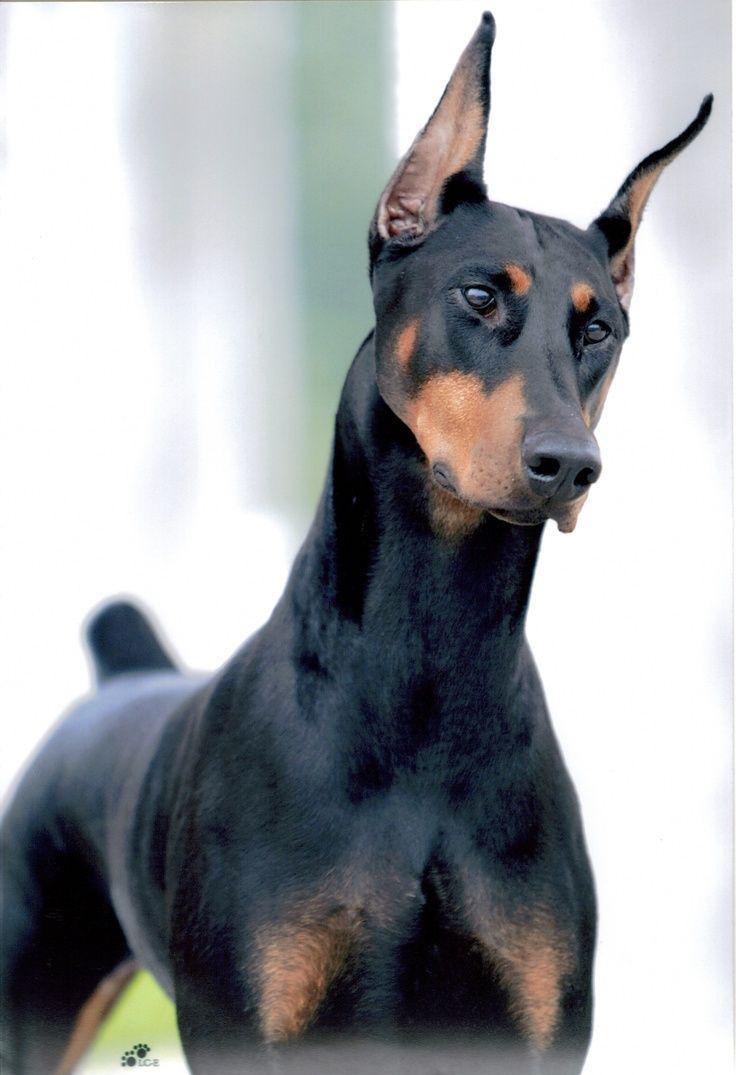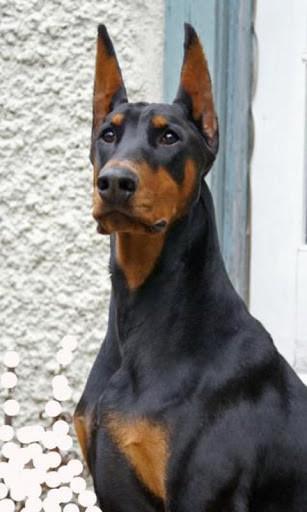The first image is the image on the left, the second image is the image on the right. Examine the images to the left and right. Is the description "The left image contains a doberman with its mouth open wide and its fangs bared, and the right image contains at least one doberman with its body and gaze facing left." accurate? Answer yes or no. No. The first image is the image on the left, the second image is the image on the right. For the images displayed, is the sentence "A doberman has its mouth open." factually correct? Answer yes or no. No. 